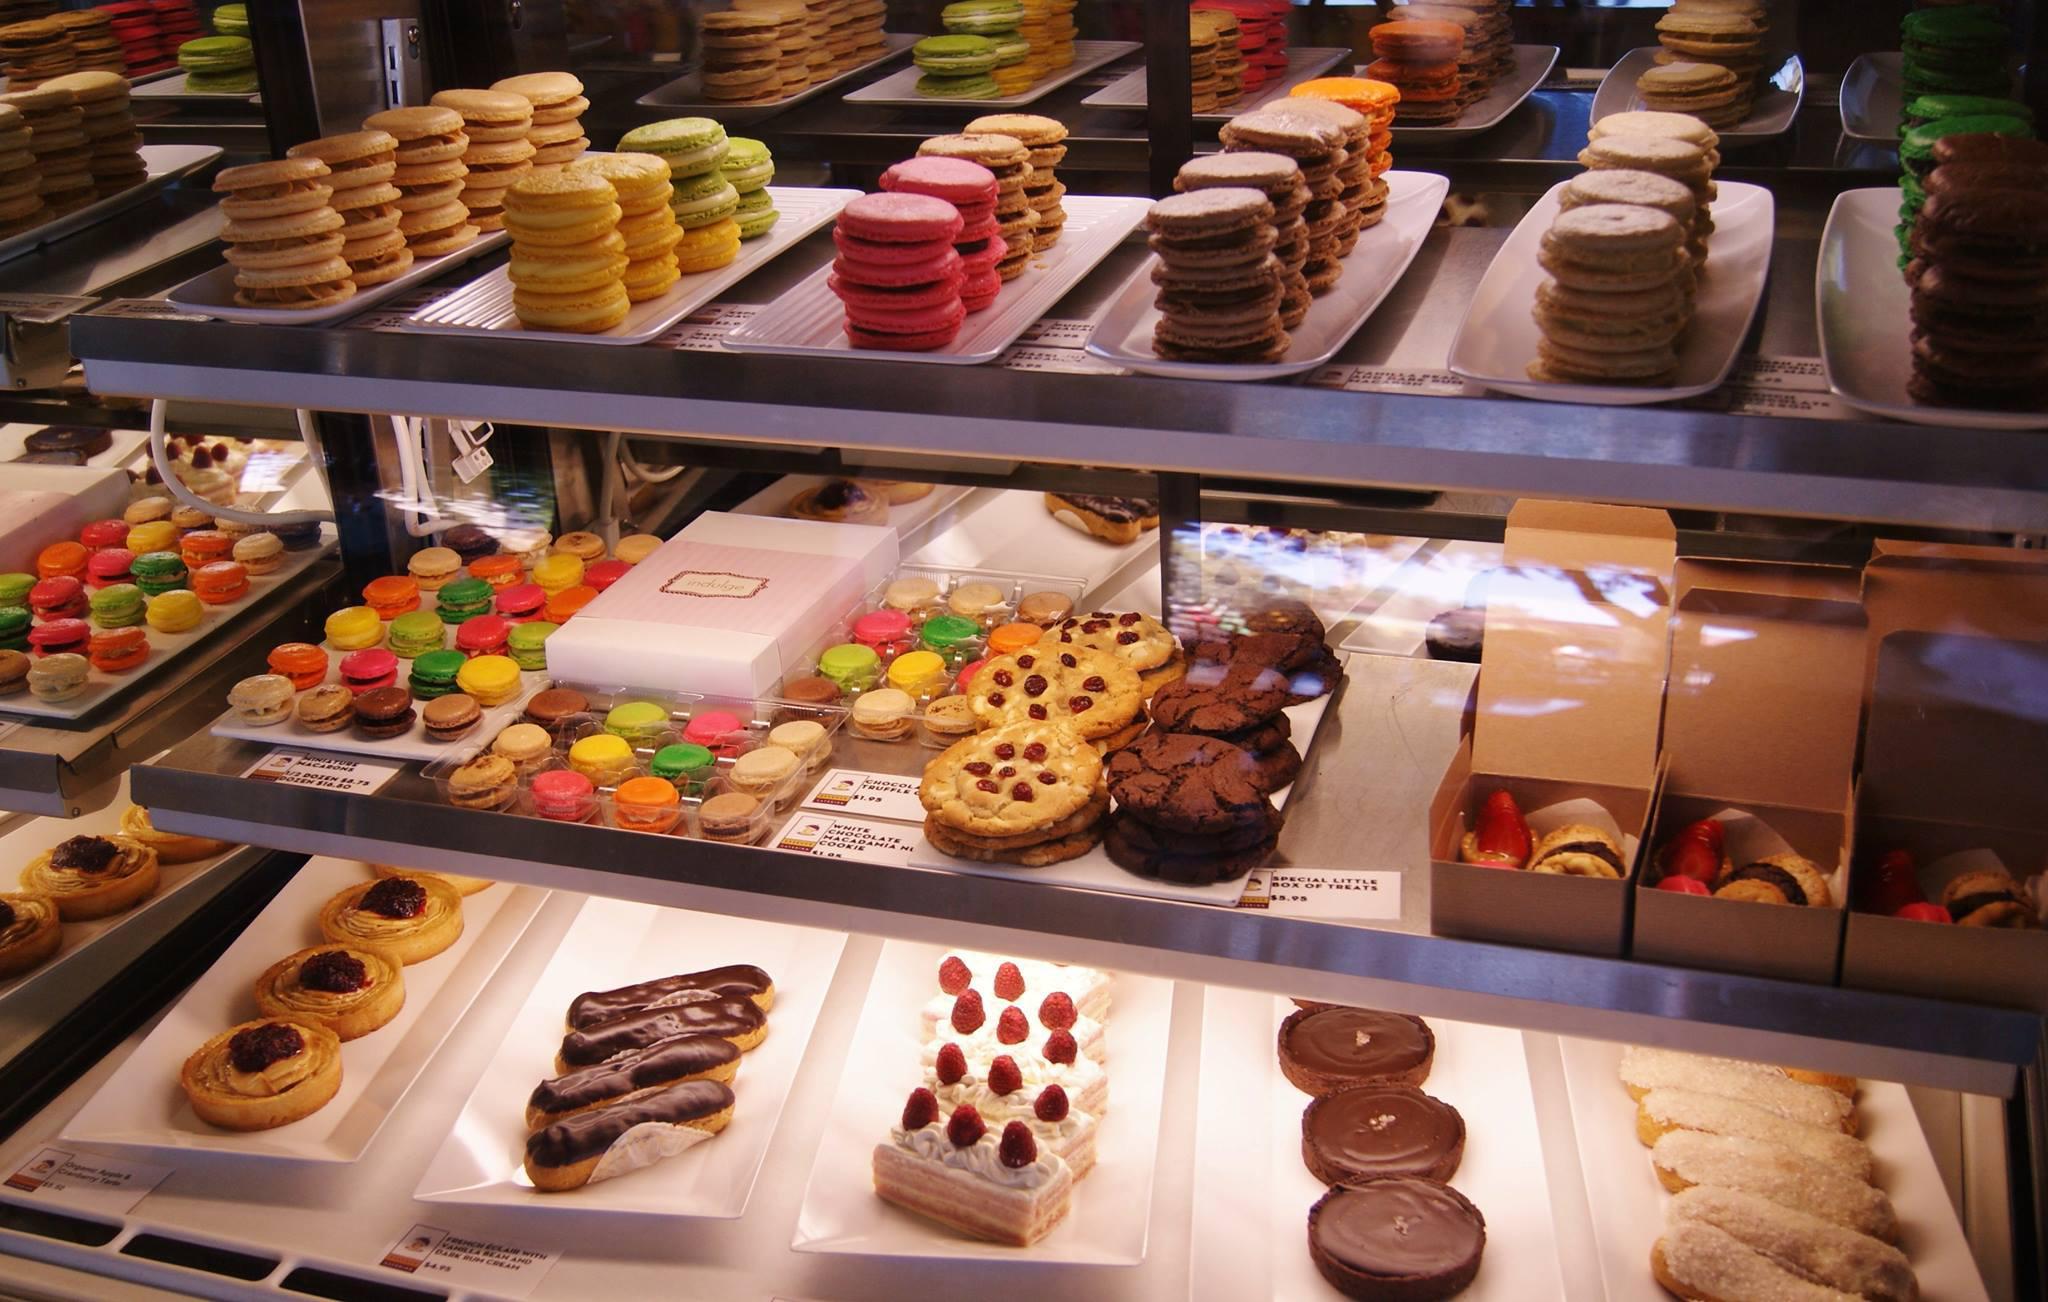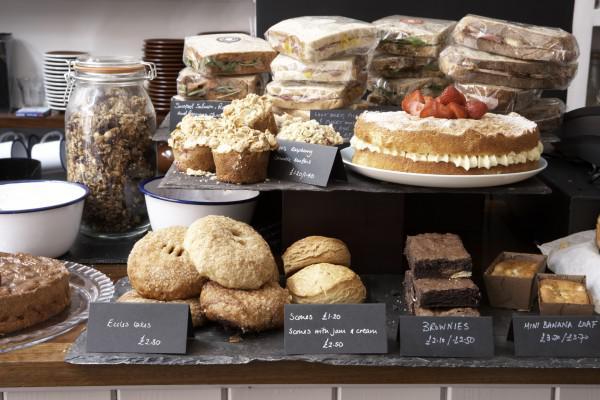The first image is the image on the left, the second image is the image on the right. Given the left and right images, does the statement "A bakery display of assorted cakes and baked goods." hold true? Answer yes or no. Yes. The first image is the image on the left, the second image is the image on the right. Given the left and right images, does the statement "The left image shows rows of bakery items on display shelves, and includes brown-frosted log shapesnext to white frosted treats garnished with red berries." hold true? Answer yes or no. Yes. 